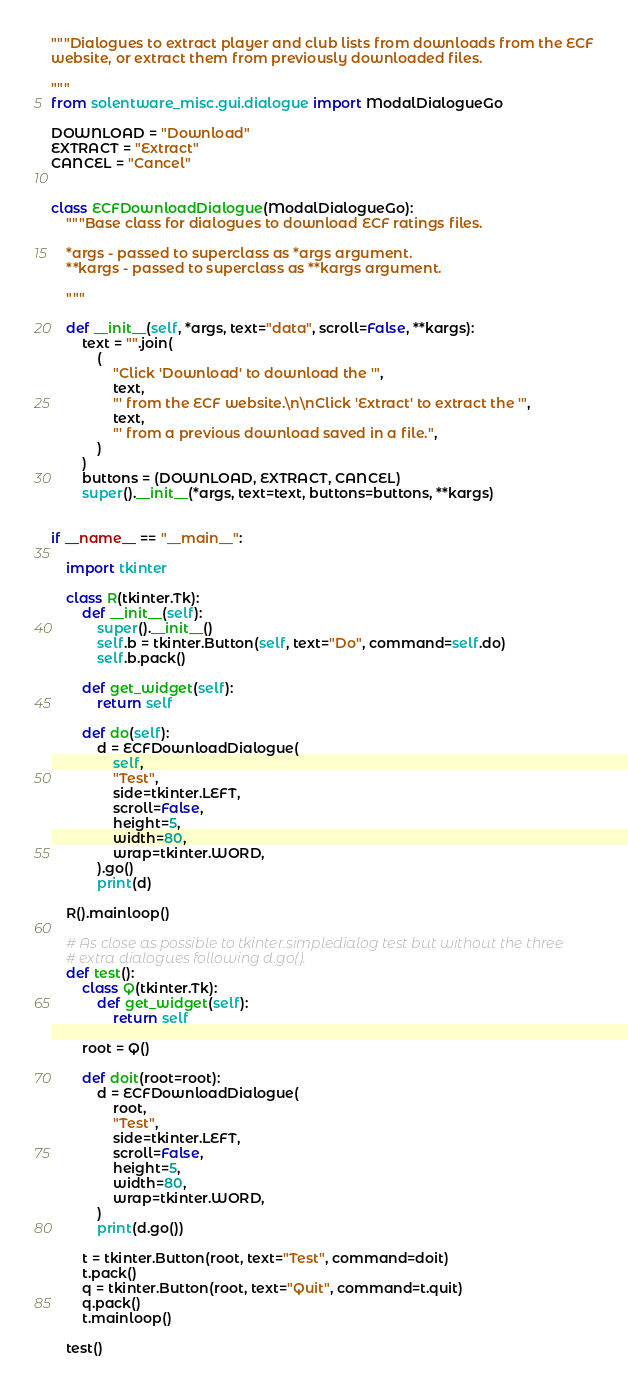Convert code to text. <code><loc_0><loc_0><loc_500><loc_500><_Python_>"""Dialogues to extract player and club lists from downloads from the ECF
website, or extract them from previously downloaded files.

"""
from solentware_misc.gui.dialogue import ModalDialogueGo

DOWNLOAD = "Download"
EXTRACT = "Extract"
CANCEL = "Cancel"


class ECFDownloadDialogue(ModalDialogueGo):
    """Base class for dialogues to download ECF ratings files.

    *args - passed to superclass as *args argument.
    **kargs - passed to superclass as **kargs argument.

    """

    def __init__(self, *args, text="data", scroll=False, **kargs):
        text = "".join(
            (
                "Click 'Download' to download the '",
                text,
                "' from the ECF website.\n\nClick 'Extract' to extract the '",
                text,
                "' from a previous download saved in a file.",
            )
        )
        buttons = (DOWNLOAD, EXTRACT, CANCEL)
        super().__init__(*args, text=text, buttons=buttons, **kargs)


if __name__ == "__main__":

    import tkinter

    class R(tkinter.Tk):
        def __init__(self):
            super().__init__()
            self.b = tkinter.Button(self, text="Do", command=self.do)
            self.b.pack()

        def get_widget(self):
            return self

        def do(self):
            d = ECFDownloadDialogue(
                self,
                "Test",
                side=tkinter.LEFT,
                scroll=False,
                height=5,
                width=80,
                wrap=tkinter.WORD,
            ).go()
            print(d)

    R().mainloop()

    # As close as possible to tkinter.simpledialog test but without the three
    # extra dialogues following d.go().
    def test():
        class Q(tkinter.Tk):
            def get_widget(self):
                return self

        root = Q()

        def doit(root=root):
            d = ECFDownloadDialogue(
                root,
                "Test",
                side=tkinter.LEFT,
                scroll=False,
                height=5,
                width=80,
                wrap=tkinter.WORD,
            )
            print(d.go())

        t = tkinter.Button(root, text="Test", command=doit)
        t.pack()
        q = tkinter.Button(root, text="Quit", command=t.quit)
        q.pack()
        t.mainloop()

    test()
</code> 